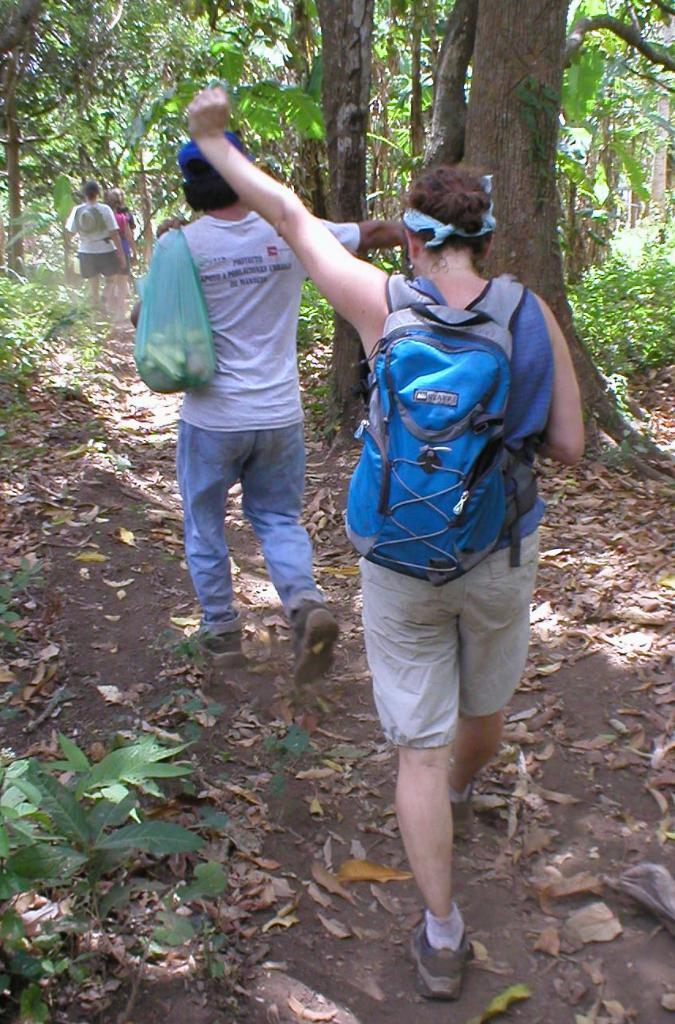In one or two sentences, can you explain what this image depicts? In this image I can see few person walking on the road. The man is wearing a bag. At the back side there are trees. 